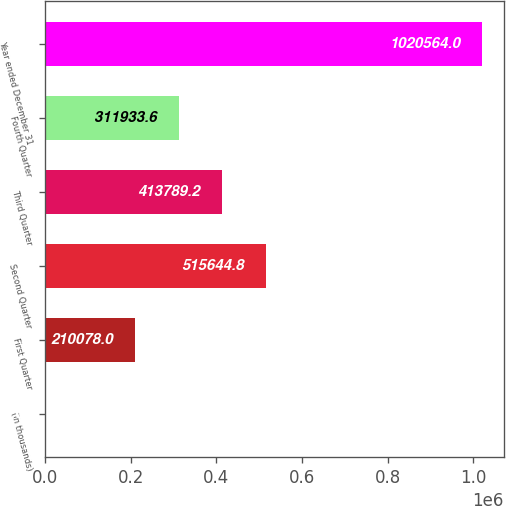Convert chart to OTSL. <chart><loc_0><loc_0><loc_500><loc_500><bar_chart><fcel>(in thousands)<fcel>First Quarter<fcel>Second Quarter<fcel>Third Quarter<fcel>Fourth Quarter<fcel>Year ended December 31<nl><fcel>2008<fcel>210078<fcel>515645<fcel>413789<fcel>311934<fcel>1.02056e+06<nl></chart> 